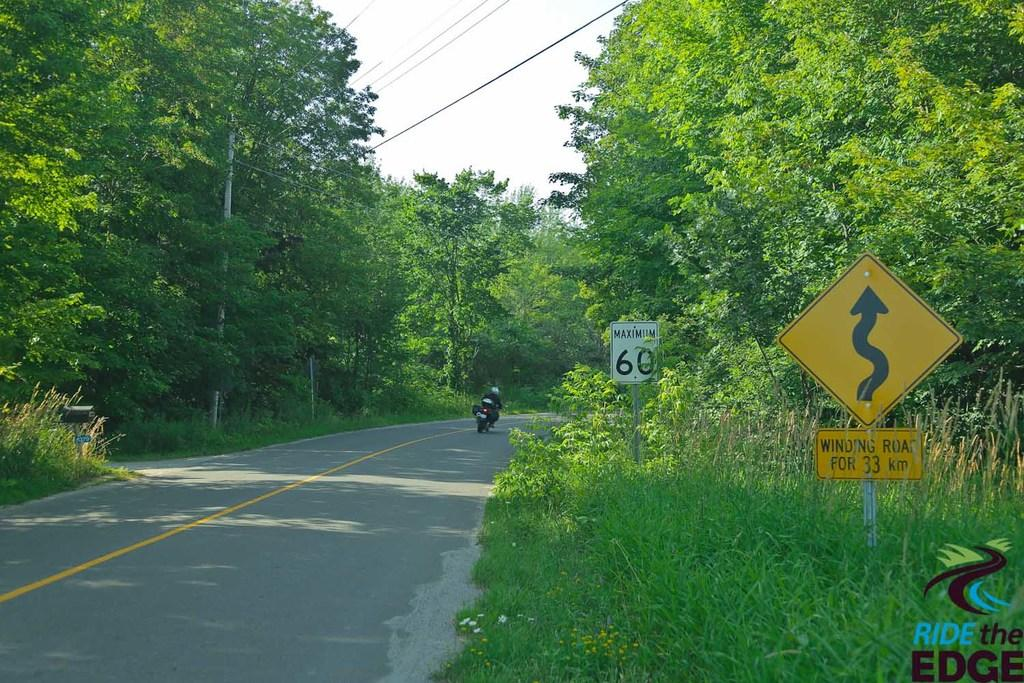<image>
Relay a brief, clear account of the picture shown. A man on a motorcycle riding down a highway passing a road sign that says maximum 60 mph. 